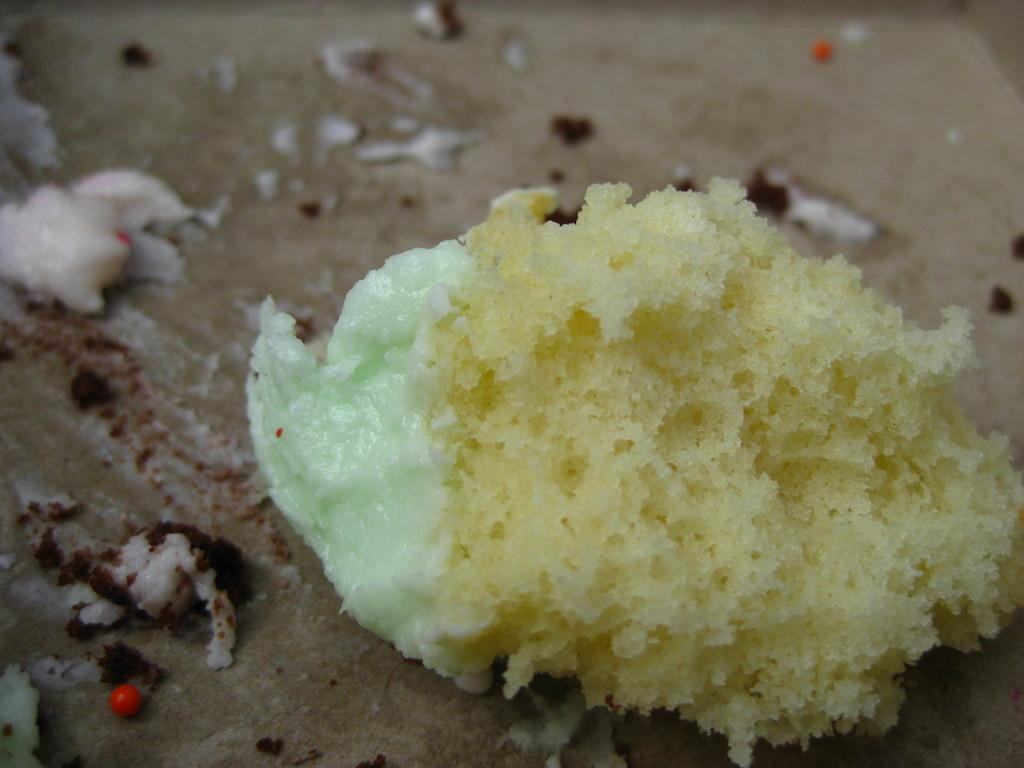What type of food is visible in the image? The food in the image has a cream and white color. Can you describe the appearance of the food? The food has a cream and white color. What type of plant can be seen in the hospital room in the image? There is no hospital or plant present in the image; it only features food with a cream and white color. 